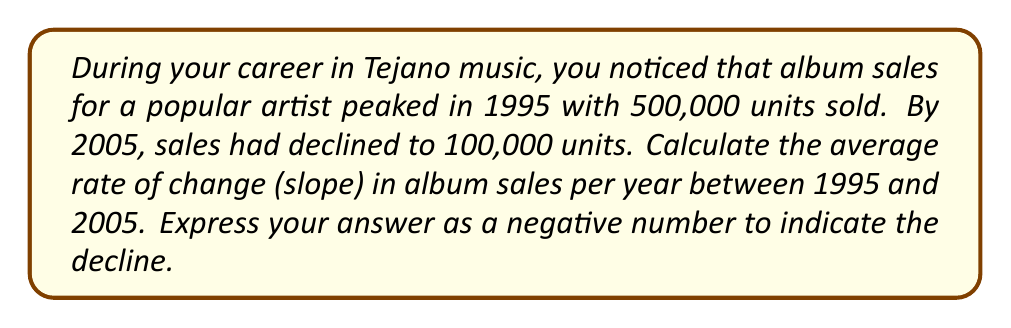Give your solution to this math problem. To calculate the rate of change (slope) in album sales, we'll use the slope formula:

$$ m = \frac{y_2 - y_1}{x_2 - x_1} $$

Where:
$m$ = slope (rate of change)
$(x_1, y_1)$ = initial point (1995, 500,000)
$(x_2, y_2)$ = final point (2005, 100,000)

Step 1: Identify the values
$x_1 = 1995$, $y_1 = 500,000$
$x_2 = 2005$, $y_2 = 100,000$

Step 2: Plug the values into the slope formula
$$ m = \frac{100,000 - 500,000}{2005 - 1995} $$

Step 3: Simplify the numerator and denominator
$$ m = \frac{-400,000}{10} $$

Step 4: Perform the division
$$ m = -40,000 $$

This means the average rate of change in album sales was a decrease of 40,000 units per year between 1995 and 2005.
Answer: $-40,000$ units/year 